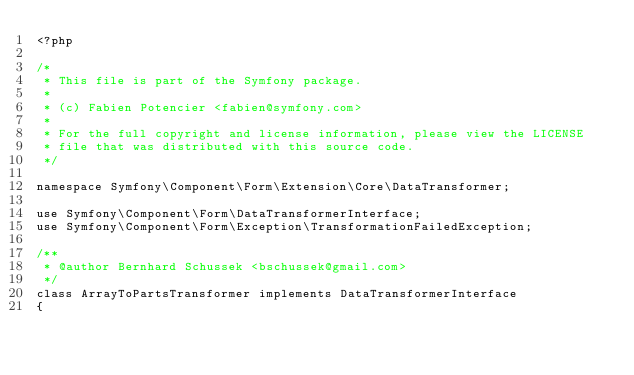Convert code to text. <code><loc_0><loc_0><loc_500><loc_500><_PHP_><?php

/*
 * This file is part of the Symfony package.
 *
 * (c) Fabien Potencier <fabien@symfony.com>
 *
 * For the full copyright and license information, please view the LICENSE
 * file that was distributed with this source code.
 */

namespace Symfony\Component\Form\Extension\Core\DataTransformer;

use Symfony\Component\Form\DataTransformerInterface;
use Symfony\Component\Form\Exception\TransformationFailedException;

/**
 * @author Bernhard Schussek <bschussek@gmail.com>
 */
class ArrayToPartsTransformer implements DataTransformerInterface
{</code> 